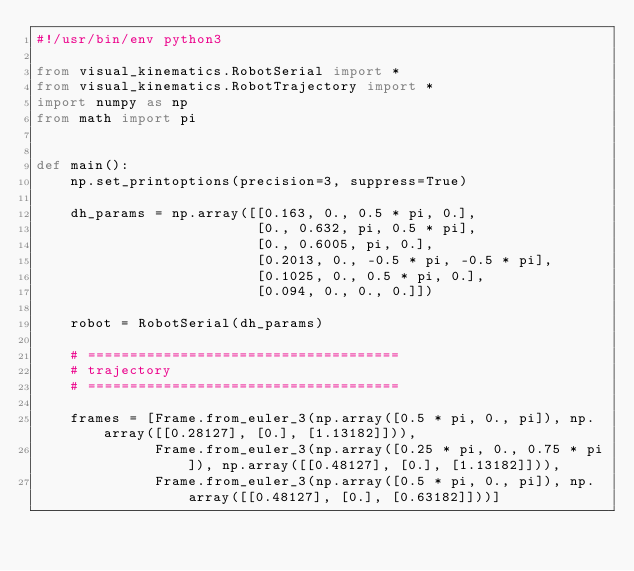<code> <loc_0><loc_0><loc_500><loc_500><_Python_>#!/usr/bin/env python3

from visual_kinematics.RobotSerial import *
from visual_kinematics.RobotTrajectory import *
import numpy as np
from math import pi


def main():
    np.set_printoptions(precision=3, suppress=True)

    dh_params = np.array([[0.163, 0., 0.5 * pi, 0.],
                          [0., 0.632, pi, 0.5 * pi],
                          [0., 0.6005, pi, 0.],
                          [0.2013, 0., -0.5 * pi, -0.5 * pi],
                          [0.1025, 0., 0.5 * pi, 0.],
                          [0.094, 0., 0., 0.]])

    robot = RobotSerial(dh_params)

    # =====================================
    # trajectory
    # =====================================

    frames = [Frame.from_euler_3(np.array([0.5 * pi, 0., pi]), np.array([[0.28127], [0.], [1.13182]])),
              Frame.from_euler_3(np.array([0.25 * pi, 0., 0.75 * pi]), np.array([[0.48127], [0.], [1.13182]])),
              Frame.from_euler_3(np.array([0.5 * pi, 0., pi]), np.array([[0.48127], [0.], [0.63182]]))]</code> 